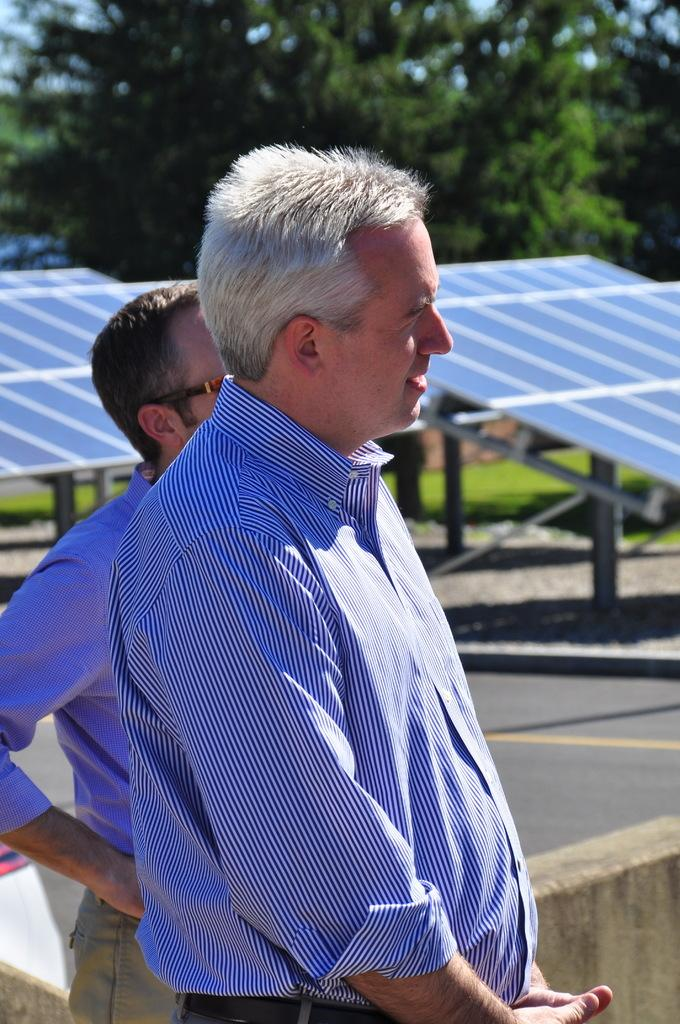What can be seen in the image involving human presence? There are people standing in the image. What type of energy source is visible in the background? There are solar panels in the background of the image. What type of natural vegetation is visible in the background? There are trees in the background of the image. What type of man-made structure is visible in the image? There is a road visible in the image. What type of water distribution system can be seen in the image? There is no water distribution system present in the image. What is the mouth of the person in the image doing? There is no person's mouth visible in the image, as the image only shows people standing. 